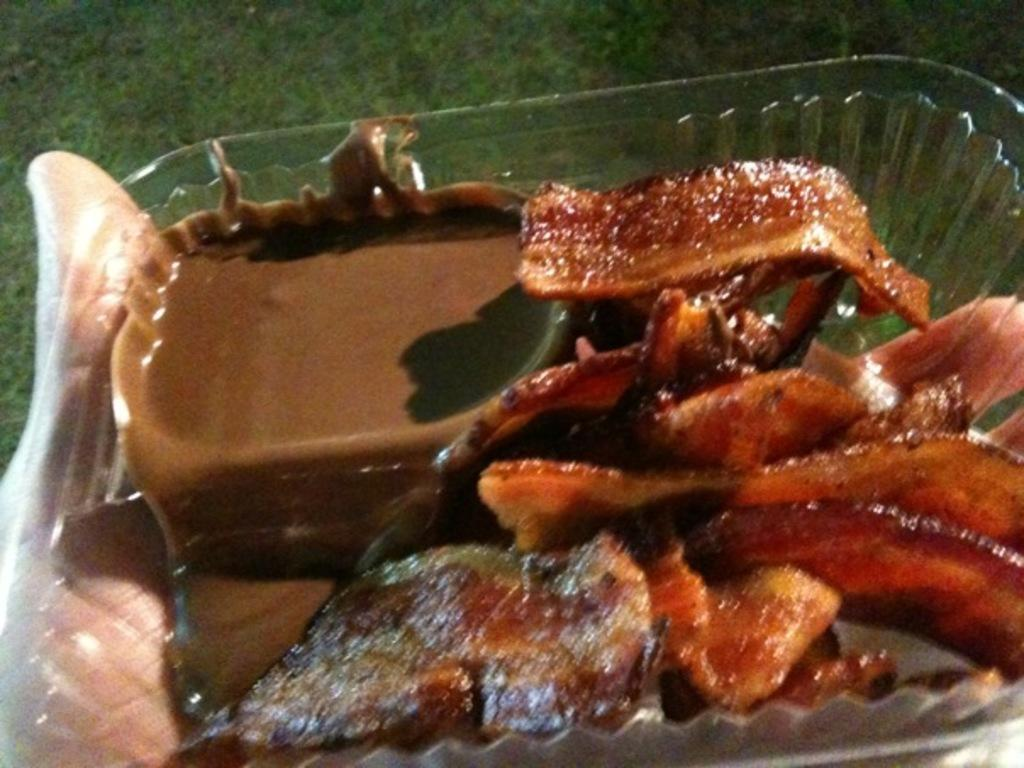What type of food can be seen in the image? There is food in the image, specifically a chocolate liquid. Can you describe the container holding the chocolate liquid? The chocolate liquid is in a transparent bowl. Who is holding the bowl in the image? A person is holding the bowl in the image. What type of request is the person making while holding the bowl in the image? There is no indication of a request being made in the image; the person is simply holding the bowl. 